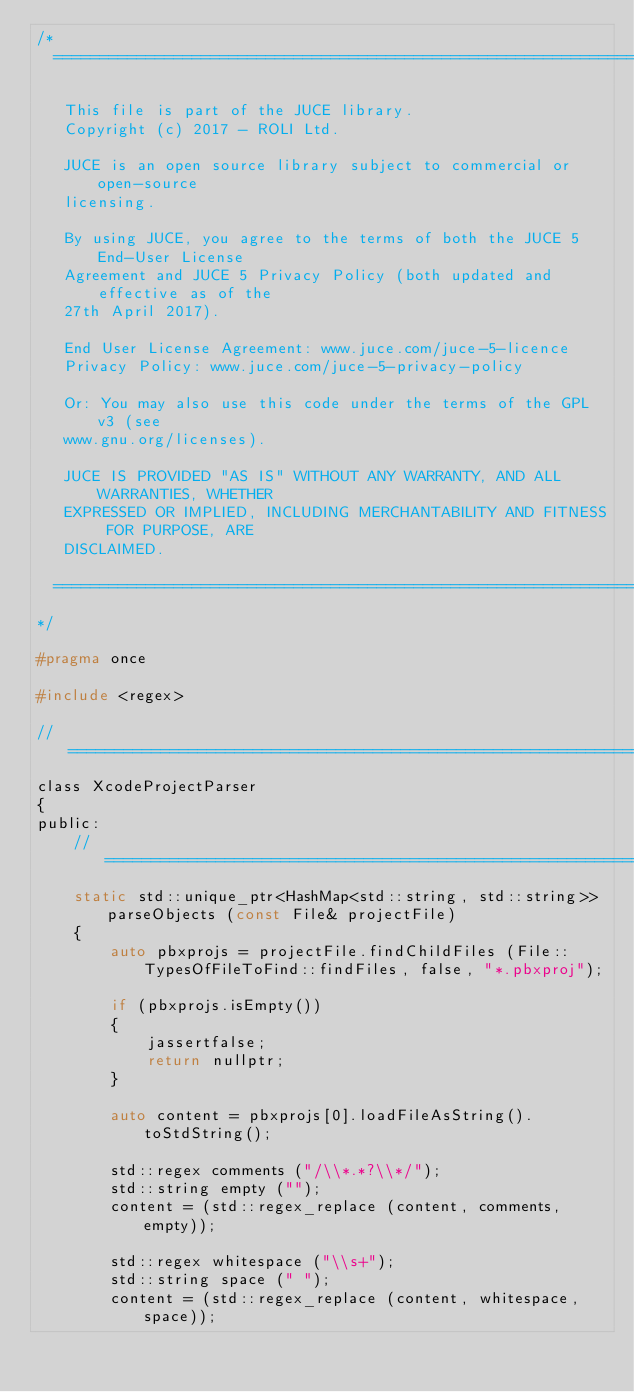Convert code to text. <code><loc_0><loc_0><loc_500><loc_500><_C_>/*
  ==============================================================================

   This file is part of the JUCE library.
   Copyright (c) 2017 - ROLI Ltd.

   JUCE is an open source library subject to commercial or open-source
   licensing.

   By using JUCE, you agree to the terms of both the JUCE 5 End-User License
   Agreement and JUCE 5 Privacy Policy (both updated and effective as of the
   27th April 2017).

   End User License Agreement: www.juce.com/juce-5-licence
   Privacy Policy: www.juce.com/juce-5-privacy-policy

   Or: You may also use this code under the terms of the GPL v3 (see
   www.gnu.org/licenses).

   JUCE IS PROVIDED "AS IS" WITHOUT ANY WARRANTY, AND ALL WARRANTIES, WHETHER
   EXPRESSED OR IMPLIED, INCLUDING MERCHANTABILITY AND FITNESS FOR PURPOSE, ARE
   DISCLAIMED.

  ==============================================================================
*/

#pragma once

#include <regex>

//==============================================================================
class XcodeProjectParser
{
public:
    //==============================================================================
    static std::unique_ptr<HashMap<std::string, std::string>> parseObjects (const File& projectFile)
    {
        auto pbxprojs = projectFile.findChildFiles (File::TypesOfFileToFind::findFiles, false, "*.pbxproj");

        if (pbxprojs.isEmpty())
        {
            jassertfalse;
            return nullptr;
        }

        auto content = pbxprojs[0].loadFileAsString().toStdString();

        std::regex comments ("/\\*.*?\\*/");
        std::string empty ("");
        content = (std::regex_replace (content, comments, empty));

        std::regex whitespace ("\\s+");
        std::string space (" ");
        content = (std::regex_replace (content, whitespace, space));
</code> 